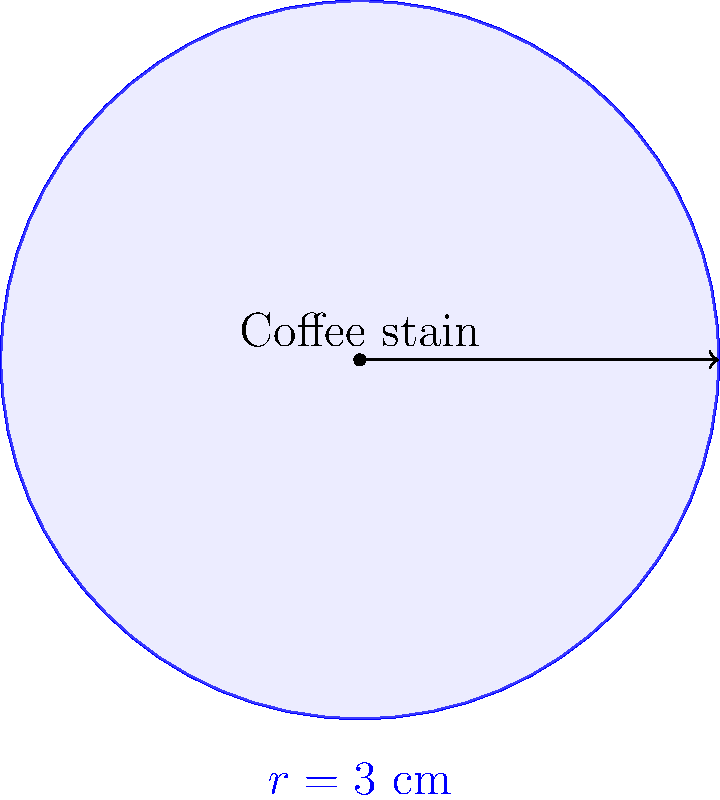While cleaning tables at the coffee shop, you notice a circular coffee stain on a napkin. If the radius of the stain is 3 cm, what is the area of the stain in square centimeters? Express your answer in terms of π. To find the area of the circular coffee stain, we can use the formula for the area of a circle:

1) The formula for the area of a circle is:
   $$A = \pi r^2$$
   where $A$ is the area and $r$ is the radius.

2) We are given that the radius is 3 cm, so we substitute this into our formula:
   $$A = \pi (3 \text{ cm})^2$$

3) Simplify the exponent:
   $$A = \pi (9 \text{ cm}^2)$$

4) Simplify further:
   $$A = 9\pi \text{ cm}^2$$

Therefore, the area of the coffee stain is $9\pi$ square centimeters.
Answer: $9\pi \text{ cm}^2$ 